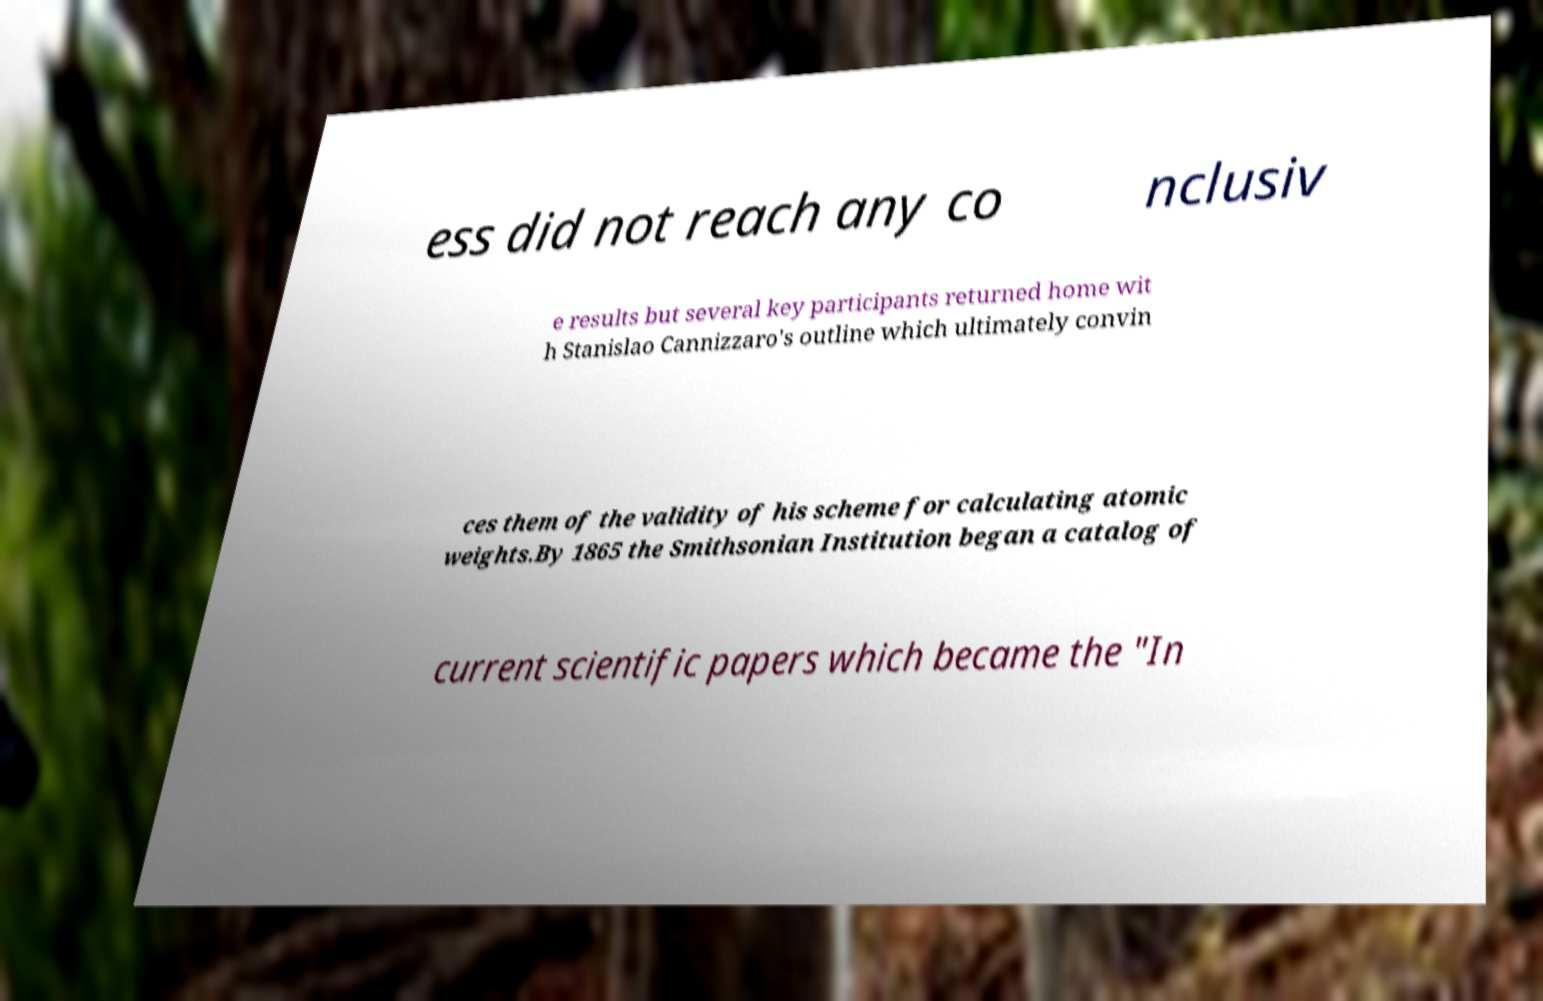Could you extract and type out the text from this image? ess did not reach any co nclusiv e results but several key participants returned home wit h Stanislao Cannizzaro's outline which ultimately convin ces them of the validity of his scheme for calculating atomic weights.By 1865 the Smithsonian Institution began a catalog of current scientific papers which became the "In 